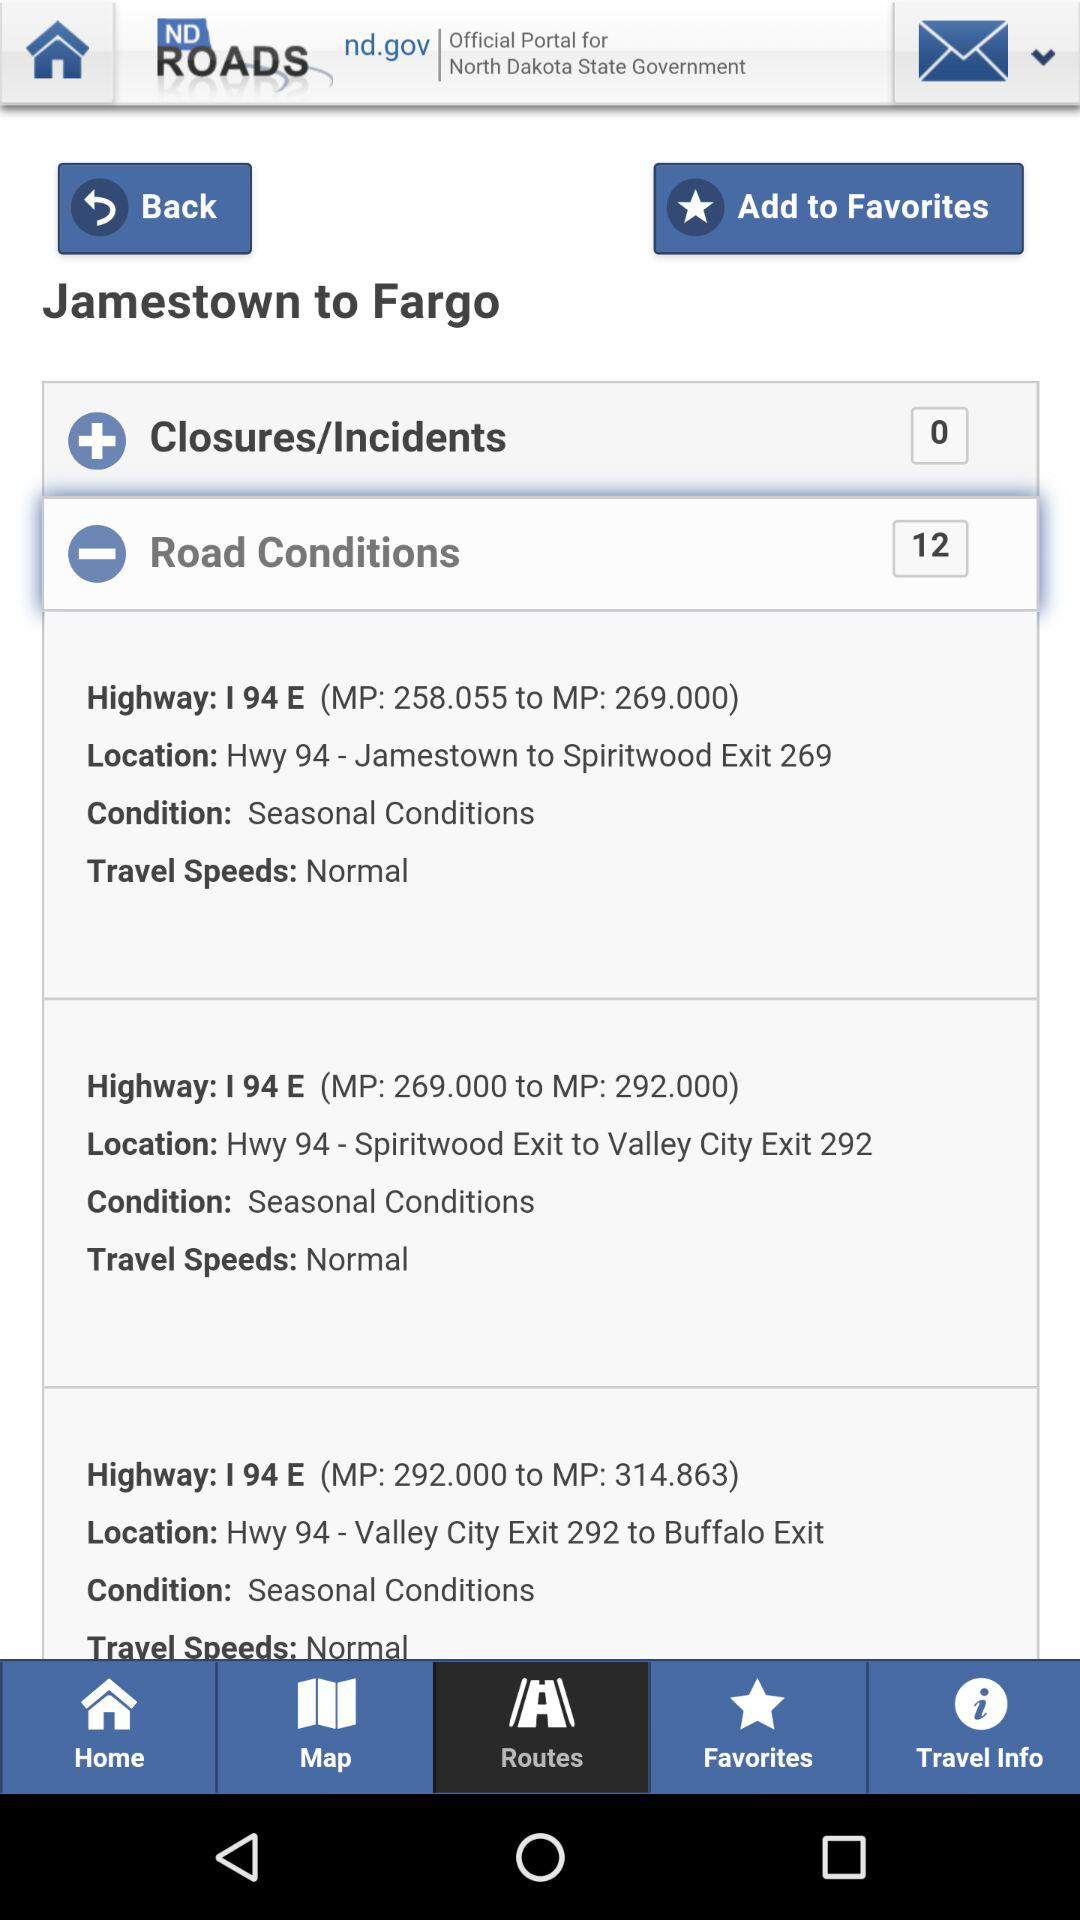What is the location of Hwy 94 (MP: 269.000 to MP: 292.000)? The location is Hwy 94 - Spiritwood Exit to Valley City Exit 292. 